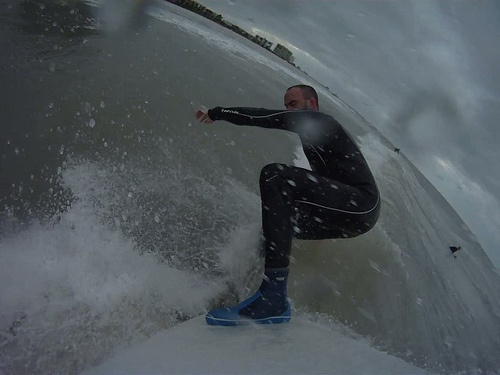Describe the objects in this image and their specific colors. I can see people in black, purple, navy, and darkblue tones, surfboard in black, gray, navy, and blue tones, and people in black and gray tones in this image. 